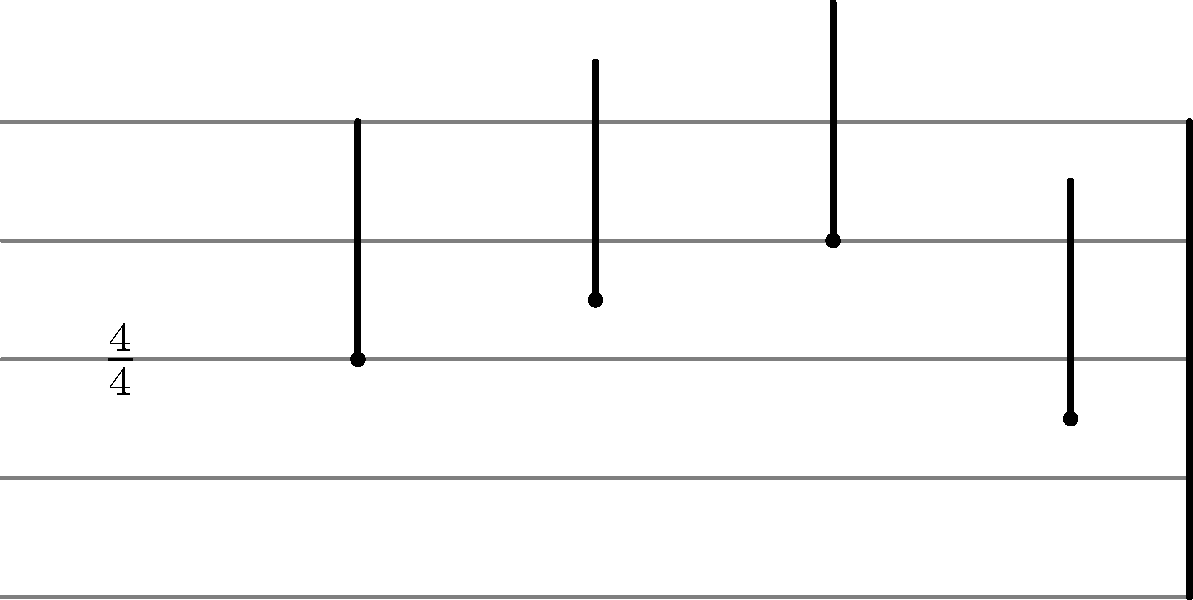As a blues musician, you're familiar with reading musical scores. Given the musical score above, what is the name of the note on the third beat of the measure? To answer this question, let's break it down step-by-step:

1. First, we need to identify the time signature. The time signature shown is 4/4, which means there are 4 beats per measure, and a quarter note gets one beat.

2. Next, we need to count the beats in the measure. There are 4 quarter notes in this measure, each representing one beat.

3. To find the third beat, we count from left to right:
   - The first beat is the lowest note on the staff
   - The second beat is the note on the second line from the bottom
   - The third beat is the note on the middle line of the staff
   - The fourth beat is the note between the bottom two lines

4. We're asked about the third beat, which is the note on the middle line of the staff.

5. In standard musical notation, the lines and spaces of the staff represent different pitches. For a treble clef (which is implied here, as it's common in blues music), the middle line represents the note B.

Therefore, the note on the third beat of the measure is B.
Answer: B 